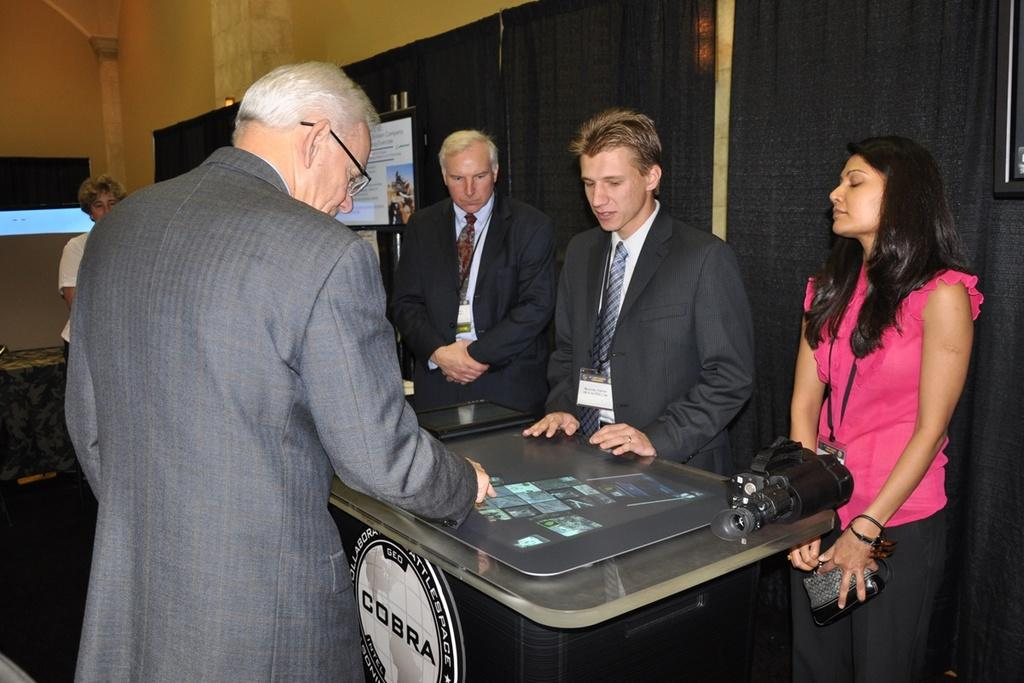How many people are present in the image? There are five persons standing in the image. What object can be seen on the table? There is a camera on the table. What else is on the table besides the camera? There are other objects on the table. What can be seen in the background of the image? There are curtains and televisions in the background of the image. What type of pear is being used to cover the television in the image? There is no pear present in the image, nor is there any object being used to cover the televisions. 